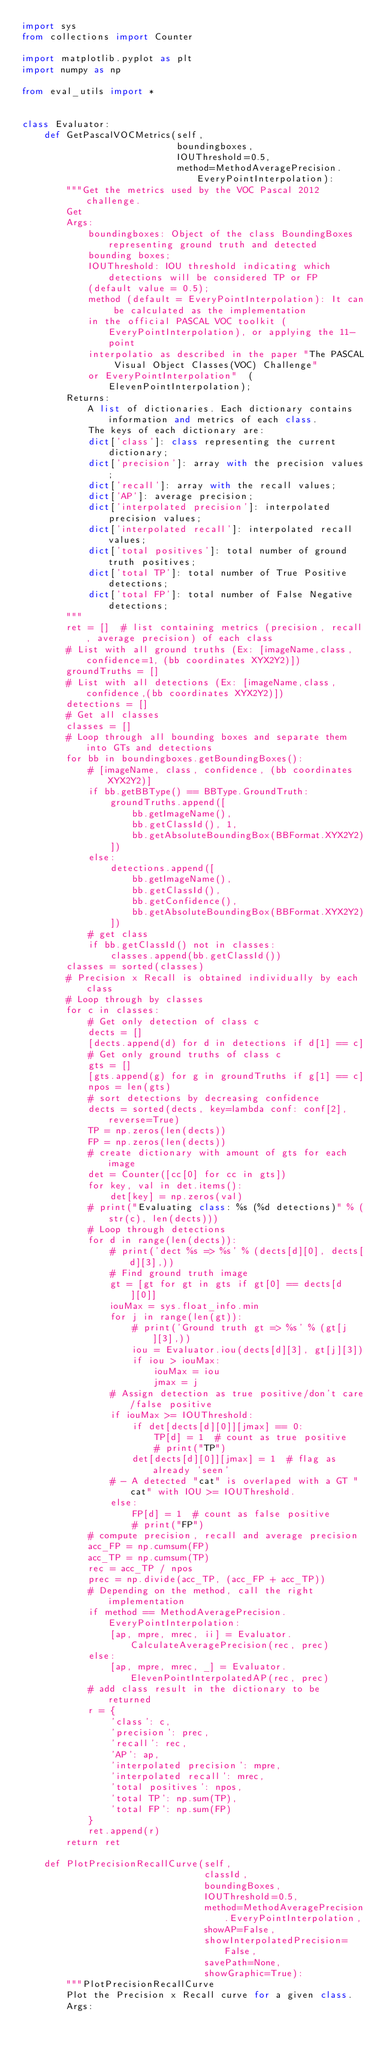Convert code to text. <code><loc_0><loc_0><loc_500><loc_500><_Python_>import sys
from collections import Counter

import matplotlib.pyplot as plt
import numpy as np

from eval_utils import *


class Evaluator:
    def GetPascalVOCMetrics(self,
                            boundingboxes,
                            IOUThreshold=0.5,
                            method=MethodAveragePrecision.EveryPointInterpolation):
        """Get the metrics used by the VOC Pascal 2012 challenge.
        Get
        Args:
            boundingboxes: Object of the class BoundingBoxes representing ground truth and detected
            bounding boxes;
            IOUThreshold: IOU threshold indicating which detections will be considered TP or FP
            (default value = 0.5);
            method (default = EveryPointInterpolation): It can be calculated as the implementation
            in the official PASCAL VOC toolkit (EveryPointInterpolation), or applying the 11-point
            interpolatio as described in the paper "The PASCAL Visual Object Classes(VOC) Challenge"
            or EveryPointInterpolation"  (ElevenPointInterpolation);
        Returns:
            A list of dictionaries. Each dictionary contains information and metrics of each class.
            The keys of each dictionary are:
            dict['class']: class representing the current dictionary;
            dict['precision']: array with the precision values;
            dict['recall']: array with the recall values;
            dict['AP']: average precision;
            dict['interpolated precision']: interpolated precision values;
            dict['interpolated recall']: interpolated recall values;
            dict['total positives']: total number of ground truth positives;
            dict['total TP']: total number of True Positive detections;
            dict['total FP']: total number of False Negative detections;
        """
        ret = []  # list containing metrics (precision, recall, average precision) of each class
        # List with all ground truths (Ex: [imageName,class,confidence=1, (bb coordinates XYX2Y2)])
        groundTruths = []
        # List with all detections (Ex: [imageName,class,confidence,(bb coordinates XYX2Y2)])
        detections = []
        # Get all classes
        classes = []
        # Loop through all bounding boxes and separate them into GTs and detections
        for bb in boundingboxes.getBoundingBoxes():
            # [imageName, class, confidence, (bb coordinates XYX2Y2)]
            if bb.getBBType() == BBType.GroundTruth:
                groundTruths.append([
                    bb.getImageName(),
                    bb.getClassId(), 1,
                    bb.getAbsoluteBoundingBox(BBFormat.XYX2Y2)
                ])
            else:
                detections.append([
                    bb.getImageName(),
                    bb.getClassId(),
                    bb.getConfidence(),
                    bb.getAbsoluteBoundingBox(BBFormat.XYX2Y2)
                ])
            # get class
            if bb.getClassId() not in classes:
                classes.append(bb.getClassId())
        classes = sorted(classes)
        # Precision x Recall is obtained individually by each class
        # Loop through by classes
        for c in classes:
            # Get only detection of class c
            dects = []
            [dects.append(d) for d in detections if d[1] == c]
            # Get only ground truths of class c
            gts = []
            [gts.append(g) for g in groundTruths if g[1] == c]
            npos = len(gts)
            # sort detections by decreasing confidence
            dects = sorted(dects, key=lambda conf: conf[2], reverse=True)
            TP = np.zeros(len(dects))
            FP = np.zeros(len(dects))
            # create dictionary with amount of gts for each image
            det = Counter([cc[0] for cc in gts])
            for key, val in det.items():
                det[key] = np.zeros(val)
            # print("Evaluating class: %s (%d detections)" % (str(c), len(dects)))
            # Loop through detections
            for d in range(len(dects)):
                # print('dect %s => %s' % (dects[d][0], dects[d][3],))
                # Find ground truth image
                gt = [gt for gt in gts if gt[0] == dects[d][0]]
                iouMax = sys.float_info.min
                for j in range(len(gt)):
                    # print('Ground truth gt => %s' % (gt[j][3],))
                    iou = Evaluator.iou(dects[d][3], gt[j][3])
                    if iou > iouMax:
                        iouMax = iou
                        jmax = j
                # Assign detection as true positive/don't care/false positive
                if iouMax >= IOUThreshold:
                    if det[dects[d][0]][jmax] == 0:
                        TP[d] = 1  # count as true positive
                        # print("TP")
                    det[dects[d][0]][jmax] = 1  # flag as already 'seen'
                # - A detected "cat" is overlaped with a GT "cat" with IOU >= IOUThreshold.
                else:
                    FP[d] = 1  # count as false positive
                    # print("FP")
            # compute precision, recall and average precision
            acc_FP = np.cumsum(FP)
            acc_TP = np.cumsum(TP)
            rec = acc_TP / npos
            prec = np.divide(acc_TP, (acc_FP + acc_TP))
            # Depending on the method, call the right implementation
            if method == MethodAveragePrecision.EveryPointInterpolation:
                [ap, mpre, mrec, ii] = Evaluator.CalculateAveragePrecision(rec, prec)
            else:
                [ap, mpre, mrec, _] = Evaluator.ElevenPointInterpolatedAP(rec, prec)
            # add class result in the dictionary to be returned
            r = {
                'class': c,
                'precision': prec,
                'recall': rec,
                'AP': ap,
                'interpolated precision': mpre,
                'interpolated recall': mrec,
                'total positives': npos,
                'total TP': np.sum(TP),
                'total FP': np.sum(FP)
            }
            ret.append(r)
        return ret

    def PlotPrecisionRecallCurve(self,
                                 classId,
                                 boundingBoxes,
                                 IOUThreshold=0.5,
                                 method=MethodAveragePrecision.EveryPointInterpolation,
                                 showAP=False,
                                 showInterpolatedPrecision=False,
                                 savePath=None,
                                 showGraphic=True):
        """PlotPrecisionRecallCurve
        Plot the Precision x Recall curve for a given class.
        Args:</code> 